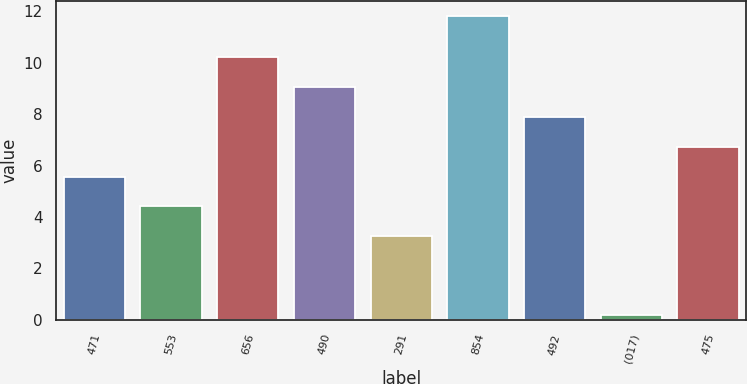Convert chart to OTSL. <chart><loc_0><loc_0><loc_500><loc_500><bar_chart><fcel>471<fcel>553<fcel>656<fcel>490<fcel>291<fcel>854<fcel>492<fcel>(017)<fcel>475<nl><fcel>5.57<fcel>4.41<fcel>10.21<fcel>9.05<fcel>3.25<fcel>11.82<fcel>7.89<fcel>0.19<fcel>6.73<nl></chart> 